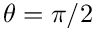Convert formula to latex. <formula><loc_0><loc_0><loc_500><loc_500>\theta = \pi / 2</formula> 